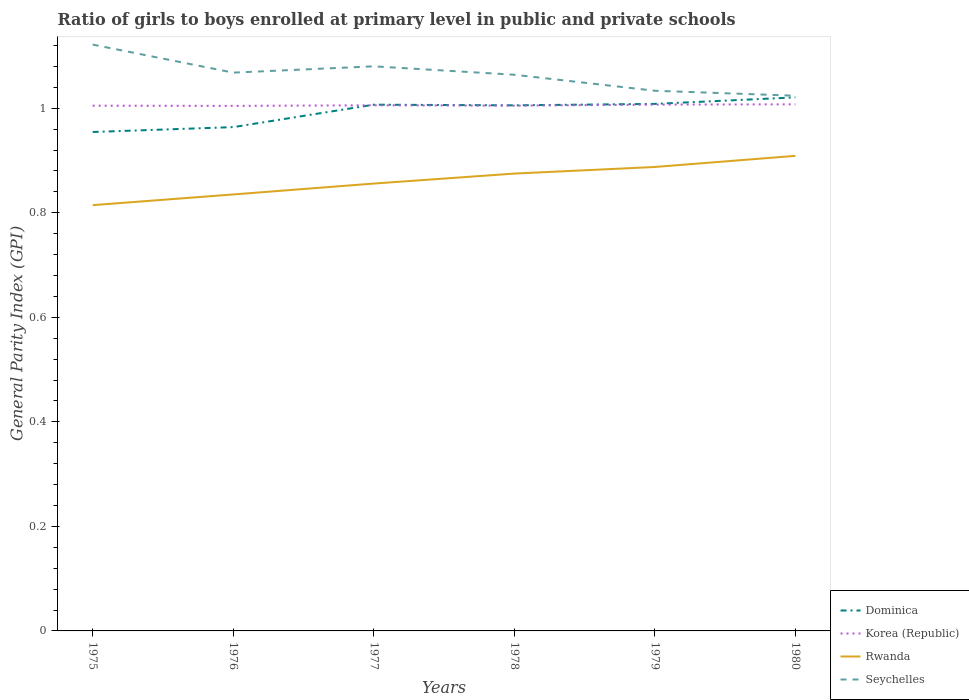Is the number of lines equal to the number of legend labels?
Offer a terse response. Yes. Across all years, what is the maximum general parity index in Seychelles?
Ensure brevity in your answer.  1.02. In which year was the general parity index in Rwanda maximum?
Your answer should be compact. 1975. What is the total general parity index in Korea (Republic) in the graph?
Provide a short and direct response. -0. What is the difference between the highest and the second highest general parity index in Korea (Republic)?
Offer a terse response. 0. Is the general parity index in Korea (Republic) strictly greater than the general parity index in Seychelles over the years?
Give a very brief answer. Yes. How many years are there in the graph?
Offer a terse response. 6. Does the graph contain any zero values?
Your response must be concise. No. Does the graph contain grids?
Give a very brief answer. No. How many legend labels are there?
Offer a terse response. 4. What is the title of the graph?
Offer a terse response. Ratio of girls to boys enrolled at primary level in public and private schools. Does "Morocco" appear as one of the legend labels in the graph?
Keep it short and to the point. No. What is the label or title of the X-axis?
Your answer should be compact. Years. What is the label or title of the Y-axis?
Ensure brevity in your answer.  General Parity Index (GPI). What is the General Parity Index (GPI) of Dominica in 1975?
Give a very brief answer. 0.95. What is the General Parity Index (GPI) in Korea (Republic) in 1975?
Provide a succinct answer. 1. What is the General Parity Index (GPI) in Rwanda in 1975?
Your answer should be very brief. 0.81. What is the General Parity Index (GPI) in Seychelles in 1975?
Provide a short and direct response. 1.12. What is the General Parity Index (GPI) of Dominica in 1976?
Ensure brevity in your answer.  0.96. What is the General Parity Index (GPI) in Korea (Republic) in 1976?
Make the answer very short. 1. What is the General Parity Index (GPI) in Rwanda in 1976?
Provide a succinct answer. 0.83. What is the General Parity Index (GPI) of Seychelles in 1976?
Ensure brevity in your answer.  1.07. What is the General Parity Index (GPI) of Dominica in 1977?
Your response must be concise. 1.01. What is the General Parity Index (GPI) in Korea (Republic) in 1977?
Make the answer very short. 1.01. What is the General Parity Index (GPI) in Rwanda in 1977?
Provide a succinct answer. 0.86. What is the General Parity Index (GPI) of Seychelles in 1977?
Offer a terse response. 1.08. What is the General Parity Index (GPI) of Dominica in 1978?
Make the answer very short. 1.01. What is the General Parity Index (GPI) of Korea (Republic) in 1978?
Ensure brevity in your answer.  1. What is the General Parity Index (GPI) of Rwanda in 1978?
Keep it short and to the point. 0.87. What is the General Parity Index (GPI) in Seychelles in 1978?
Your answer should be very brief. 1.06. What is the General Parity Index (GPI) of Dominica in 1979?
Ensure brevity in your answer.  1.01. What is the General Parity Index (GPI) in Korea (Republic) in 1979?
Your answer should be very brief. 1.01. What is the General Parity Index (GPI) in Rwanda in 1979?
Your answer should be compact. 0.89. What is the General Parity Index (GPI) of Seychelles in 1979?
Keep it short and to the point. 1.03. What is the General Parity Index (GPI) in Dominica in 1980?
Give a very brief answer. 1.02. What is the General Parity Index (GPI) of Korea (Republic) in 1980?
Offer a terse response. 1.01. What is the General Parity Index (GPI) of Rwanda in 1980?
Your response must be concise. 0.91. What is the General Parity Index (GPI) of Seychelles in 1980?
Offer a very short reply. 1.02. Across all years, what is the maximum General Parity Index (GPI) of Dominica?
Your answer should be very brief. 1.02. Across all years, what is the maximum General Parity Index (GPI) of Korea (Republic)?
Your answer should be very brief. 1.01. Across all years, what is the maximum General Parity Index (GPI) in Rwanda?
Your answer should be very brief. 0.91. Across all years, what is the maximum General Parity Index (GPI) of Seychelles?
Offer a terse response. 1.12. Across all years, what is the minimum General Parity Index (GPI) in Dominica?
Give a very brief answer. 0.95. Across all years, what is the minimum General Parity Index (GPI) of Korea (Republic)?
Give a very brief answer. 1. Across all years, what is the minimum General Parity Index (GPI) of Rwanda?
Make the answer very short. 0.81. Across all years, what is the minimum General Parity Index (GPI) of Seychelles?
Make the answer very short. 1.02. What is the total General Parity Index (GPI) of Dominica in the graph?
Your answer should be very brief. 5.96. What is the total General Parity Index (GPI) in Korea (Republic) in the graph?
Make the answer very short. 6.03. What is the total General Parity Index (GPI) in Rwanda in the graph?
Make the answer very short. 5.18. What is the total General Parity Index (GPI) in Seychelles in the graph?
Provide a succinct answer. 6.39. What is the difference between the General Parity Index (GPI) of Dominica in 1975 and that in 1976?
Provide a short and direct response. -0.01. What is the difference between the General Parity Index (GPI) in Rwanda in 1975 and that in 1976?
Your response must be concise. -0.02. What is the difference between the General Parity Index (GPI) of Seychelles in 1975 and that in 1976?
Make the answer very short. 0.05. What is the difference between the General Parity Index (GPI) in Dominica in 1975 and that in 1977?
Keep it short and to the point. -0.05. What is the difference between the General Parity Index (GPI) in Korea (Republic) in 1975 and that in 1977?
Provide a succinct answer. -0. What is the difference between the General Parity Index (GPI) of Rwanda in 1975 and that in 1977?
Give a very brief answer. -0.04. What is the difference between the General Parity Index (GPI) in Seychelles in 1975 and that in 1977?
Your answer should be very brief. 0.04. What is the difference between the General Parity Index (GPI) of Dominica in 1975 and that in 1978?
Your response must be concise. -0.05. What is the difference between the General Parity Index (GPI) of Rwanda in 1975 and that in 1978?
Give a very brief answer. -0.06. What is the difference between the General Parity Index (GPI) in Seychelles in 1975 and that in 1978?
Keep it short and to the point. 0.06. What is the difference between the General Parity Index (GPI) in Dominica in 1975 and that in 1979?
Your response must be concise. -0.05. What is the difference between the General Parity Index (GPI) in Korea (Republic) in 1975 and that in 1979?
Your response must be concise. -0. What is the difference between the General Parity Index (GPI) of Rwanda in 1975 and that in 1979?
Provide a succinct answer. -0.07. What is the difference between the General Parity Index (GPI) of Seychelles in 1975 and that in 1979?
Provide a short and direct response. 0.09. What is the difference between the General Parity Index (GPI) of Dominica in 1975 and that in 1980?
Provide a short and direct response. -0.07. What is the difference between the General Parity Index (GPI) of Korea (Republic) in 1975 and that in 1980?
Provide a short and direct response. -0. What is the difference between the General Parity Index (GPI) in Rwanda in 1975 and that in 1980?
Your answer should be very brief. -0.09. What is the difference between the General Parity Index (GPI) in Seychelles in 1975 and that in 1980?
Offer a very short reply. 0.1. What is the difference between the General Parity Index (GPI) of Dominica in 1976 and that in 1977?
Your answer should be compact. -0.04. What is the difference between the General Parity Index (GPI) of Korea (Republic) in 1976 and that in 1977?
Give a very brief answer. -0. What is the difference between the General Parity Index (GPI) in Rwanda in 1976 and that in 1977?
Offer a terse response. -0.02. What is the difference between the General Parity Index (GPI) of Seychelles in 1976 and that in 1977?
Ensure brevity in your answer.  -0.01. What is the difference between the General Parity Index (GPI) of Dominica in 1976 and that in 1978?
Your answer should be very brief. -0.04. What is the difference between the General Parity Index (GPI) of Korea (Republic) in 1976 and that in 1978?
Offer a terse response. -0. What is the difference between the General Parity Index (GPI) of Rwanda in 1976 and that in 1978?
Keep it short and to the point. -0.04. What is the difference between the General Parity Index (GPI) in Seychelles in 1976 and that in 1978?
Ensure brevity in your answer.  0. What is the difference between the General Parity Index (GPI) of Dominica in 1976 and that in 1979?
Keep it short and to the point. -0.04. What is the difference between the General Parity Index (GPI) in Korea (Republic) in 1976 and that in 1979?
Give a very brief answer. -0. What is the difference between the General Parity Index (GPI) of Rwanda in 1976 and that in 1979?
Your response must be concise. -0.05. What is the difference between the General Parity Index (GPI) of Seychelles in 1976 and that in 1979?
Provide a short and direct response. 0.03. What is the difference between the General Parity Index (GPI) in Dominica in 1976 and that in 1980?
Your answer should be very brief. -0.06. What is the difference between the General Parity Index (GPI) of Korea (Republic) in 1976 and that in 1980?
Provide a short and direct response. -0. What is the difference between the General Parity Index (GPI) in Rwanda in 1976 and that in 1980?
Keep it short and to the point. -0.07. What is the difference between the General Parity Index (GPI) in Seychelles in 1976 and that in 1980?
Ensure brevity in your answer.  0.04. What is the difference between the General Parity Index (GPI) of Dominica in 1977 and that in 1978?
Ensure brevity in your answer.  0. What is the difference between the General Parity Index (GPI) of Korea (Republic) in 1977 and that in 1978?
Your response must be concise. 0. What is the difference between the General Parity Index (GPI) in Rwanda in 1977 and that in 1978?
Ensure brevity in your answer.  -0.02. What is the difference between the General Parity Index (GPI) in Seychelles in 1977 and that in 1978?
Offer a very short reply. 0.02. What is the difference between the General Parity Index (GPI) of Dominica in 1977 and that in 1979?
Keep it short and to the point. -0. What is the difference between the General Parity Index (GPI) of Korea (Republic) in 1977 and that in 1979?
Make the answer very short. -0. What is the difference between the General Parity Index (GPI) of Rwanda in 1977 and that in 1979?
Provide a succinct answer. -0.03. What is the difference between the General Parity Index (GPI) in Seychelles in 1977 and that in 1979?
Give a very brief answer. 0.05. What is the difference between the General Parity Index (GPI) in Dominica in 1977 and that in 1980?
Offer a terse response. -0.01. What is the difference between the General Parity Index (GPI) of Korea (Republic) in 1977 and that in 1980?
Make the answer very short. -0. What is the difference between the General Parity Index (GPI) in Rwanda in 1977 and that in 1980?
Your answer should be compact. -0.05. What is the difference between the General Parity Index (GPI) in Seychelles in 1977 and that in 1980?
Provide a short and direct response. 0.06. What is the difference between the General Parity Index (GPI) of Dominica in 1978 and that in 1979?
Make the answer very short. -0. What is the difference between the General Parity Index (GPI) in Korea (Republic) in 1978 and that in 1979?
Offer a terse response. -0. What is the difference between the General Parity Index (GPI) in Rwanda in 1978 and that in 1979?
Provide a short and direct response. -0.01. What is the difference between the General Parity Index (GPI) in Seychelles in 1978 and that in 1979?
Ensure brevity in your answer.  0.03. What is the difference between the General Parity Index (GPI) in Dominica in 1978 and that in 1980?
Your answer should be compact. -0.02. What is the difference between the General Parity Index (GPI) in Korea (Republic) in 1978 and that in 1980?
Keep it short and to the point. -0. What is the difference between the General Parity Index (GPI) of Rwanda in 1978 and that in 1980?
Make the answer very short. -0.03. What is the difference between the General Parity Index (GPI) of Seychelles in 1978 and that in 1980?
Provide a succinct answer. 0.04. What is the difference between the General Parity Index (GPI) of Dominica in 1979 and that in 1980?
Keep it short and to the point. -0.01. What is the difference between the General Parity Index (GPI) in Korea (Republic) in 1979 and that in 1980?
Offer a very short reply. -0. What is the difference between the General Parity Index (GPI) in Rwanda in 1979 and that in 1980?
Make the answer very short. -0.02. What is the difference between the General Parity Index (GPI) of Seychelles in 1979 and that in 1980?
Provide a short and direct response. 0.01. What is the difference between the General Parity Index (GPI) in Dominica in 1975 and the General Parity Index (GPI) in Korea (Republic) in 1976?
Provide a short and direct response. -0.05. What is the difference between the General Parity Index (GPI) of Dominica in 1975 and the General Parity Index (GPI) of Rwanda in 1976?
Offer a terse response. 0.12. What is the difference between the General Parity Index (GPI) of Dominica in 1975 and the General Parity Index (GPI) of Seychelles in 1976?
Keep it short and to the point. -0.11. What is the difference between the General Parity Index (GPI) in Korea (Republic) in 1975 and the General Parity Index (GPI) in Rwanda in 1976?
Your answer should be very brief. 0.17. What is the difference between the General Parity Index (GPI) in Korea (Republic) in 1975 and the General Parity Index (GPI) in Seychelles in 1976?
Offer a very short reply. -0.06. What is the difference between the General Parity Index (GPI) of Rwanda in 1975 and the General Parity Index (GPI) of Seychelles in 1976?
Provide a short and direct response. -0.25. What is the difference between the General Parity Index (GPI) of Dominica in 1975 and the General Parity Index (GPI) of Korea (Republic) in 1977?
Your response must be concise. -0.05. What is the difference between the General Parity Index (GPI) of Dominica in 1975 and the General Parity Index (GPI) of Rwanda in 1977?
Your answer should be very brief. 0.1. What is the difference between the General Parity Index (GPI) in Dominica in 1975 and the General Parity Index (GPI) in Seychelles in 1977?
Offer a terse response. -0.13. What is the difference between the General Parity Index (GPI) in Korea (Republic) in 1975 and the General Parity Index (GPI) in Rwanda in 1977?
Provide a short and direct response. 0.15. What is the difference between the General Parity Index (GPI) in Korea (Republic) in 1975 and the General Parity Index (GPI) in Seychelles in 1977?
Give a very brief answer. -0.08. What is the difference between the General Parity Index (GPI) of Rwanda in 1975 and the General Parity Index (GPI) of Seychelles in 1977?
Make the answer very short. -0.27. What is the difference between the General Parity Index (GPI) in Dominica in 1975 and the General Parity Index (GPI) in Korea (Republic) in 1978?
Offer a terse response. -0.05. What is the difference between the General Parity Index (GPI) in Dominica in 1975 and the General Parity Index (GPI) in Rwanda in 1978?
Keep it short and to the point. 0.08. What is the difference between the General Parity Index (GPI) of Dominica in 1975 and the General Parity Index (GPI) of Seychelles in 1978?
Your response must be concise. -0.11. What is the difference between the General Parity Index (GPI) of Korea (Republic) in 1975 and the General Parity Index (GPI) of Rwanda in 1978?
Provide a short and direct response. 0.13. What is the difference between the General Parity Index (GPI) of Korea (Republic) in 1975 and the General Parity Index (GPI) of Seychelles in 1978?
Offer a terse response. -0.06. What is the difference between the General Parity Index (GPI) in Rwanda in 1975 and the General Parity Index (GPI) in Seychelles in 1978?
Ensure brevity in your answer.  -0.25. What is the difference between the General Parity Index (GPI) of Dominica in 1975 and the General Parity Index (GPI) of Korea (Republic) in 1979?
Your response must be concise. -0.05. What is the difference between the General Parity Index (GPI) of Dominica in 1975 and the General Parity Index (GPI) of Rwanda in 1979?
Offer a terse response. 0.07. What is the difference between the General Parity Index (GPI) in Dominica in 1975 and the General Parity Index (GPI) in Seychelles in 1979?
Provide a short and direct response. -0.08. What is the difference between the General Parity Index (GPI) of Korea (Republic) in 1975 and the General Parity Index (GPI) of Rwanda in 1979?
Provide a succinct answer. 0.12. What is the difference between the General Parity Index (GPI) in Korea (Republic) in 1975 and the General Parity Index (GPI) in Seychelles in 1979?
Your response must be concise. -0.03. What is the difference between the General Parity Index (GPI) of Rwanda in 1975 and the General Parity Index (GPI) of Seychelles in 1979?
Offer a terse response. -0.22. What is the difference between the General Parity Index (GPI) of Dominica in 1975 and the General Parity Index (GPI) of Korea (Republic) in 1980?
Provide a succinct answer. -0.05. What is the difference between the General Parity Index (GPI) of Dominica in 1975 and the General Parity Index (GPI) of Rwanda in 1980?
Make the answer very short. 0.05. What is the difference between the General Parity Index (GPI) of Dominica in 1975 and the General Parity Index (GPI) of Seychelles in 1980?
Your answer should be compact. -0.07. What is the difference between the General Parity Index (GPI) in Korea (Republic) in 1975 and the General Parity Index (GPI) in Rwanda in 1980?
Make the answer very short. 0.1. What is the difference between the General Parity Index (GPI) of Korea (Republic) in 1975 and the General Parity Index (GPI) of Seychelles in 1980?
Provide a short and direct response. -0.02. What is the difference between the General Parity Index (GPI) of Rwanda in 1975 and the General Parity Index (GPI) of Seychelles in 1980?
Offer a very short reply. -0.21. What is the difference between the General Parity Index (GPI) of Dominica in 1976 and the General Parity Index (GPI) of Korea (Republic) in 1977?
Give a very brief answer. -0.04. What is the difference between the General Parity Index (GPI) in Dominica in 1976 and the General Parity Index (GPI) in Rwanda in 1977?
Ensure brevity in your answer.  0.11. What is the difference between the General Parity Index (GPI) of Dominica in 1976 and the General Parity Index (GPI) of Seychelles in 1977?
Your answer should be very brief. -0.12. What is the difference between the General Parity Index (GPI) in Korea (Republic) in 1976 and the General Parity Index (GPI) in Rwanda in 1977?
Give a very brief answer. 0.15. What is the difference between the General Parity Index (GPI) of Korea (Republic) in 1976 and the General Parity Index (GPI) of Seychelles in 1977?
Offer a very short reply. -0.08. What is the difference between the General Parity Index (GPI) of Rwanda in 1976 and the General Parity Index (GPI) of Seychelles in 1977?
Your response must be concise. -0.25. What is the difference between the General Parity Index (GPI) in Dominica in 1976 and the General Parity Index (GPI) in Korea (Republic) in 1978?
Offer a terse response. -0.04. What is the difference between the General Parity Index (GPI) in Dominica in 1976 and the General Parity Index (GPI) in Rwanda in 1978?
Provide a succinct answer. 0.09. What is the difference between the General Parity Index (GPI) in Dominica in 1976 and the General Parity Index (GPI) in Seychelles in 1978?
Provide a short and direct response. -0.1. What is the difference between the General Parity Index (GPI) in Korea (Republic) in 1976 and the General Parity Index (GPI) in Rwanda in 1978?
Your answer should be compact. 0.13. What is the difference between the General Parity Index (GPI) of Korea (Republic) in 1976 and the General Parity Index (GPI) of Seychelles in 1978?
Your response must be concise. -0.06. What is the difference between the General Parity Index (GPI) in Rwanda in 1976 and the General Parity Index (GPI) in Seychelles in 1978?
Your response must be concise. -0.23. What is the difference between the General Parity Index (GPI) of Dominica in 1976 and the General Parity Index (GPI) of Korea (Republic) in 1979?
Your response must be concise. -0.04. What is the difference between the General Parity Index (GPI) in Dominica in 1976 and the General Parity Index (GPI) in Rwanda in 1979?
Provide a succinct answer. 0.08. What is the difference between the General Parity Index (GPI) in Dominica in 1976 and the General Parity Index (GPI) in Seychelles in 1979?
Keep it short and to the point. -0.07. What is the difference between the General Parity Index (GPI) in Korea (Republic) in 1976 and the General Parity Index (GPI) in Rwanda in 1979?
Give a very brief answer. 0.12. What is the difference between the General Parity Index (GPI) in Korea (Republic) in 1976 and the General Parity Index (GPI) in Seychelles in 1979?
Make the answer very short. -0.03. What is the difference between the General Parity Index (GPI) of Rwanda in 1976 and the General Parity Index (GPI) of Seychelles in 1979?
Your answer should be very brief. -0.2. What is the difference between the General Parity Index (GPI) in Dominica in 1976 and the General Parity Index (GPI) in Korea (Republic) in 1980?
Make the answer very short. -0.04. What is the difference between the General Parity Index (GPI) in Dominica in 1976 and the General Parity Index (GPI) in Rwanda in 1980?
Ensure brevity in your answer.  0.06. What is the difference between the General Parity Index (GPI) in Dominica in 1976 and the General Parity Index (GPI) in Seychelles in 1980?
Give a very brief answer. -0.06. What is the difference between the General Parity Index (GPI) of Korea (Republic) in 1976 and the General Parity Index (GPI) of Rwanda in 1980?
Make the answer very short. 0.1. What is the difference between the General Parity Index (GPI) of Korea (Republic) in 1976 and the General Parity Index (GPI) of Seychelles in 1980?
Your answer should be very brief. -0.02. What is the difference between the General Parity Index (GPI) in Rwanda in 1976 and the General Parity Index (GPI) in Seychelles in 1980?
Your answer should be very brief. -0.19. What is the difference between the General Parity Index (GPI) in Dominica in 1977 and the General Parity Index (GPI) in Korea (Republic) in 1978?
Provide a succinct answer. 0. What is the difference between the General Parity Index (GPI) of Dominica in 1977 and the General Parity Index (GPI) of Rwanda in 1978?
Provide a succinct answer. 0.13. What is the difference between the General Parity Index (GPI) in Dominica in 1977 and the General Parity Index (GPI) in Seychelles in 1978?
Provide a short and direct response. -0.06. What is the difference between the General Parity Index (GPI) in Korea (Republic) in 1977 and the General Parity Index (GPI) in Rwanda in 1978?
Give a very brief answer. 0.13. What is the difference between the General Parity Index (GPI) of Korea (Republic) in 1977 and the General Parity Index (GPI) of Seychelles in 1978?
Keep it short and to the point. -0.06. What is the difference between the General Parity Index (GPI) in Rwanda in 1977 and the General Parity Index (GPI) in Seychelles in 1978?
Your response must be concise. -0.21. What is the difference between the General Parity Index (GPI) of Dominica in 1977 and the General Parity Index (GPI) of Korea (Republic) in 1979?
Your answer should be compact. -0. What is the difference between the General Parity Index (GPI) in Dominica in 1977 and the General Parity Index (GPI) in Rwanda in 1979?
Keep it short and to the point. 0.12. What is the difference between the General Parity Index (GPI) in Dominica in 1977 and the General Parity Index (GPI) in Seychelles in 1979?
Offer a terse response. -0.03. What is the difference between the General Parity Index (GPI) in Korea (Republic) in 1977 and the General Parity Index (GPI) in Rwanda in 1979?
Make the answer very short. 0.12. What is the difference between the General Parity Index (GPI) of Korea (Republic) in 1977 and the General Parity Index (GPI) of Seychelles in 1979?
Provide a succinct answer. -0.03. What is the difference between the General Parity Index (GPI) of Rwanda in 1977 and the General Parity Index (GPI) of Seychelles in 1979?
Offer a terse response. -0.18. What is the difference between the General Parity Index (GPI) in Dominica in 1977 and the General Parity Index (GPI) in Korea (Republic) in 1980?
Provide a short and direct response. -0. What is the difference between the General Parity Index (GPI) of Dominica in 1977 and the General Parity Index (GPI) of Rwanda in 1980?
Your answer should be very brief. 0.1. What is the difference between the General Parity Index (GPI) of Dominica in 1977 and the General Parity Index (GPI) of Seychelles in 1980?
Keep it short and to the point. -0.02. What is the difference between the General Parity Index (GPI) in Korea (Republic) in 1977 and the General Parity Index (GPI) in Rwanda in 1980?
Your response must be concise. 0.1. What is the difference between the General Parity Index (GPI) of Korea (Republic) in 1977 and the General Parity Index (GPI) of Seychelles in 1980?
Offer a terse response. -0.02. What is the difference between the General Parity Index (GPI) of Rwanda in 1977 and the General Parity Index (GPI) of Seychelles in 1980?
Your answer should be compact. -0.17. What is the difference between the General Parity Index (GPI) of Dominica in 1978 and the General Parity Index (GPI) of Korea (Republic) in 1979?
Provide a short and direct response. -0. What is the difference between the General Parity Index (GPI) of Dominica in 1978 and the General Parity Index (GPI) of Rwanda in 1979?
Provide a short and direct response. 0.12. What is the difference between the General Parity Index (GPI) of Dominica in 1978 and the General Parity Index (GPI) of Seychelles in 1979?
Make the answer very short. -0.03. What is the difference between the General Parity Index (GPI) in Korea (Republic) in 1978 and the General Parity Index (GPI) in Rwanda in 1979?
Provide a succinct answer. 0.12. What is the difference between the General Parity Index (GPI) in Korea (Republic) in 1978 and the General Parity Index (GPI) in Seychelles in 1979?
Keep it short and to the point. -0.03. What is the difference between the General Parity Index (GPI) in Rwanda in 1978 and the General Parity Index (GPI) in Seychelles in 1979?
Provide a succinct answer. -0.16. What is the difference between the General Parity Index (GPI) in Dominica in 1978 and the General Parity Index (GPI) in Korea (Republic) in 1980?
Offer a terse response. -0. What is the difference between the General Parity Index (GPI) in Dominica in 1978 and the General Parity Index (GPI) in Rwanda in 1980?
Give a very brief answer. 0.1. What is the difference between the General Parity Index (GPI) of Dominica in 1978 and the General Parity Index (GPI) of Seychelles in 1980?
Your answer should be very brief. -0.02. What is the difference between the General Parity Index (GPI) in Korea (Republic) in 1978 and the General Parity Index (GPI) in Rwanda in 1980?
Offer a terse response. 0.1. What is the difference between the General Parity Index (GPI) in Korea (Republic) in 1978 and the General Parity Index (GPI) in Seychelles in 1980?
Offer a very short reply. -0.02. What is the difference between the General Parity Index (GPI) in Rwanda in 1978 and the General Parity Index (GPI) in Seychelles in 1980?
Offer a terse response. -0.15. What is the difference between the General Parity Index (GPI) in Dominica in 1979 and the General Parity Index (GPI) in Korea (Republic) in 1980?
Provide a succinct answer. 0. What is the difference between the General Parity Index (GPI) of Dominica in 1979 and the General Parity Index (GPI) of Rwanda in 1980?
Provide a short and direct response. 0.1. What is the difference between the General Parity Index (GPI) in Dominica in 1979 and the General Parity Index (GPI) in Seychelles in 1980?
Keep it short and to the point. -0.02. What is the difference between the General Parity Index (GPI) in Korea (Republic) in 1979 and the General Parity Index (GPI) in Rwanda in 1980?
Offer a terse response. 0.1. What is the difference between the General Parity Index (GPI) in Korea (Republic) in 1979 and the General Parity Index (GPI) in Seychelles in 1980?
Offer a terse response. -0.02. What is the difference between the General Parity Index (GPI) of Rwanda in 1979 and the General Parity Index (GPI) of Seychelles in 1980?
Offer a very short reply. -0.14. What is the average General Parity Index (GPI) in Dominica per year?
Ensure brevity in your answer.  0.99. What is the average General Parity Index (GPI) in Korea (Republic) per year?
Your answer should be very brief. 1.01. What is the average General Parity Index (GPI) in Rwanda per year?
Make the answer very short. 0.86. What is the average General Parity Index (GPI) of Seychelles per year?
Make the answer very short. 1.07. In the year 1975, what is the difference between the General Parity Index (GPI) of Dominica and General Parity Index (GPI) of Korea (Republic)?
Provide a short and direct response. -0.05. In the year 1975, what is the difference between the General Parity Index (GPI) in Dominica and General Parity Index (GPI) in Rwanda?
Your answer should be very brief. 0.14. In the year 1975, what is the difference between the General Parity Index (GPI) of Dominica and General Parity Index (GPI) of Seychelles?
Your answer should be very brief. -0.17. In the year 1975, what is the difference between the General Parity Index (GPI) in Korea (Republic) and General Parity Index (GPI) in Rwanda?
Offer a terse response. 0.19. In the year 1975, what is the difference between the General Parity Index (GPI) in Korea (Republic) and General Parity Index (GPI) in Seychelles?
Provide a succinct answer. -0.12. In the year 1975, what is the difference between the General Parity Index (GPI) of Rwanda and General Parity Index (GPI) of Seychelles?
Provide a short and direct response. -0.31. In the year 1976, what is the difference between the General Parity Index (GPI) in Dominica and General Parity Index (GPI) in Korea (Republic)?
Your answer should be very brief. -0.04. In the year 1976, what is the difference between the General Parity Index (GPI) in Dominica and General Parity Index (GPI) in Rwanda?
Ensure brevity in your answer.  0.13. In the year 1976, what is the difference between the General Parity Index (GPI) of Dominica and General Parity Index (GPI) of Seychelles?
Your response must be concise. -0.1. In the year 1976, what is the difference between the General Parity Index (GPI) of Korea (Republic) and General Parity Index (GPI) of Rwanda?
Provide a succinct answer. 0.17. In the year 1976, what is the difference between the General Parity Index (GPI) in Korea (Republic) and General Parity Index (GPI) in Seychelles?
Your answer should be compact. -0.06. In the year 1976, what is the difference between the General Parity Index (GPI) of Rwanda and General Parity Index (GPI) of Seychelles?
Your response must be concise. -0.23. In the year 1977, what is the difference between the General Parity Index (GPI) of Dominica and General Parity Index (GPI) of Korea (Republic)?
Your answer should be very brief. 0. In the year 1977, what is the difference between the General Parity Index (GPI) of Dominica and General Parity Index (GPI) of Rwanda?
Make the answer very short. 0.15. In the year 1977, what is the difference between the General Parity Index (GPI) of Dominica and General Parity Index (GPI) of Seychelles?
Make the answer very short. -0.07. In the year 1977, what is the difference between the General Parity Index (GPI) of Korea (Republic) and General Parity Index (GPI) of Rwanda?
Your answer should be very brief. 0.15. In the year 1977, what is the difference between the General Parity Index (GPI) in Korea (Republic) and General Parity Index (GPI) in Seychelles?
Your answer should be very brief. -0.07. In the year 1977, what is the difference between the General Parity Index (GPI) in Rwanda and General Parity Index (GPI) in Seychelles?
Provide a succinct answer. -0.22. In the year 1978, what is the difference between the General Parity Index (GPI) of Dominica and General Parity Index (GPI) of Korea (Republic)?
Your answer should be very brief. 0. In the year 1978, what is the difference between the General Parity Index (GPI) of Dominica and General Parity Index (GPI) of Rwanda?
Your response must be concise. 0.13. In the year 1978, what is the difference between the General Parity Index (GPI) in Dominica and General Parity Index (GPI) in Seychelles?
Ensure brevity in your answer.  -0.06. In the year 1978, what is the difference between the General Parity Index (GPI) of Korea (Republic) and General Parity Index (GPI) of Rwanda?
Offer a terse response. 0.13. In the year 1978, what is the difference between the General Parity Index (GPI) of Korea (Republic) and General Parity Index (GPI) of Seychelles?
Provide a succinct answer. -0.06. In the year 1978, what is the difference between the General Parity Index (GPI) in Rwanda and General Parity Index (GPI) in Seychelles?
Your response must be concise. -0.19. In the year 1979, what is the difference between the General Parity Index (GPI) of Dominica and General Parity Index (GPI) of Korea (Republic)?
Offer a terse response. 0. In the year 1979, what is the difference between the General Parity Index (GPI) in Dominica and General Parity Index (GPI) in Rwanda?
Give a very brief answer. 0.12. In the year 1979, what is the difference between the General Parity Index (GPI) in Dominica and General Parity Index (GPI) in Seychelles?
Give a very brief answer. -0.03. In the year 1979, what is the difference between the General Parity Index (GPI) of Korea (Republic) and General Parity Index (GPI) of Rwanda?
Offer a terse response. 0.12. In the year 1979, what is the difference between the General Parity Index (GPI) of Korea (Republic) and General Parity Index (GPI) of Seychelles?
Provide a succinct answer. -0.03. In the year 1979, what is the difference between the General Parity Index (GPI) of Rwanda and General Parity Index (GPI) of Seychelles?
Keep it short and to the point. -0.15. In the year 1980, what is the difference between the General Parity Index (GPI) of Dominica and General Parity Index (GPI) of Korea (Republic)?
Make the answer very short. 0.01. In the year 1980, what is the difference between the General Parity Index (GPI) of Dominica and General Parity Index (GPI) of Rwanda?
Your response must be concise. 0.11. In the year 1980, what is the difference between the General Parity Index (GPI) in Dominica and General Parity Index (GPI) in Seychelles?
Provide a succinct answer. -0. In the year 1980, what is the difference between the General Parity Index (GPI) of Korea (Republic) and General Parity Index (GPI) of Rwanda?
Make the answer very short. 0.1. In the year 1980, what is the difference between the General Parity Index (GPI) of Korea (Republic) and General Parity Index (GPI) of Seychelles?
Make the answer very short. -0.02. In the year 1980, what is the difference between the General Parity Index (GPI) in Rwanda and General Parity Index (GPI) in Seychelles?
Provide a short and direct response. -0.12. What is the ratio of the General Parity Index (GPI) in Dominica in 1975 to that in 1976?
Offer a very short reply. 0.99. What is the ratio of the General Parity Index (GPI) of Korea (Republic) in 1975 to that in 1976?
Offer a terse response. 1. What is the ratio of the General Parity Index (GPI) in Rwanda in 1975 to that in 1976?
Give a very brief answer. 0.98. What is the ratio of the General Parity Index (GPI) of Seychelles in 1975 to that in 1976?
Ensure brevity in your answer.  1.05. What is the ratio of the General Parity Index (GPI) of Dominica in 1975 to that in 1977?
Keep it short and to the point. 0.95. What is the ratio of the General Parity Index (GPI) of Korea (Republic) in 1975 to that in 1977?
Ensure brevity in your answer.  1. What is the ratio of the General Parity Index (GPI) of Rwanda in 1975 to that in 1977?
Keep it short and to the point. 0.95. What is the ratio of the General Parity Index (GPI) in Seychelles in 1975 to that in 1977?
Your answer should be compact. 1.04. What is the ratio of the General Parity Index (GPI) in Dominica in 1975 to that in 1978?
Ensure brevity in your answer.  0.95. What is the ratio of the General Parity Index (GPI) of Korea (Republic) in 1975 to that in 1978?
Your answer should be very brief. 1. What is the ratio of the General Parity Index (GPI) of Rwanda in 1975 to that in 1978?
Your answer should be compact. 0.93. What is the ratio of the General Parity Index (GPI) in Seychelles in 1975 to that in 1978?
Your response must be concise. 1.05. What is the ratio of the General Parity Index (GPI) in Dominica in 1975 to that in 1979?
Your answer should be very brief. 0.95. What is the ratio of the General Parity Index (GPI) of Rwanda in 1975 to that in 1979?
Give a very brief answer. 0.92. What is the ratio of the General Parity Index (GPI) in Seychelles in 1975 to that in 1979?
Your answer should be very brief. 1.09. What is the ratio of the General Parity Index (GPI) in Dominica in 1975 to that in 1980?
Make the answer very short. 0.94. What is the ratio of the General Parity Index (GPI) in Korea (Republic) in 1975 to that in 1980?
Your response must be concise. 1. What is the ratio of the General Parity Index (GPI) in Rwanda in 1975 to that in 1980?
Your answer should be compact. 0.9. What is the ratio of the General Parity Index (GPI) in Seychelles in 1975 to that in 1980?
Make the answer very short. 1.1. What is the ratio of the General Parity Index (GPI) of Dominica in 1976 to that in 1977?
Ensure brevity in your answer.  0.96. What is the ratio of the General Parity Index (GPI) of Rwanda in 1976 to that in 1977?
Your response must be concise. 0.98. What is the ratio of the General Parity Index (GPI) of Seychelles in 1976 to that in 1977?
Make the answer very short. 0.99. What is the ratio of the General Parity Index (GPI) of Dominica in 1976 to that in 1978?
Your answer should be compact. 0.96. What is the ratio of the General Parity Index (GPI) in Rwanda in 1976 to that in 1978?
Your response must be concise. 0.95. What is the ratio of the General Parity Index (GPI) in Seychelles in 1976 to that in 1978?
Provide a succinct answer. 1. What is the ratio of the General Parity Index (GPI) in Dominica in 1976 to that in 1979?
Make the answer very short. 0.96. What is the ratio of the General Parity Index (GPI) of Rwanda in 1976 to that in 1979?
Offer a terse response. 0.94. What is the ratio of the General Parity Index (GPI) of Seychelles in 1976 to that in 1979?
Offer a very short reply. 1.03. What is the ratio of the General Parity Index (GPI) of Dominica in 1976 to that in 1980?
Keep it short and to the point. 0.94. What is the ratio of the General Parity Index (GPI) of Korea (Republic) in 1976 to that in 1980?
Offer a terse response. 1. What is the ratio of the General Parity Index (GPI) in Rwanda in 1976 to that in 1980?
Offer a terse response. 0.92. What is the ratio of the General Parity Index (GPI) in Seychelles in 1976 to that in 1980?
Offer a terse response. 1.04. What is the ratio of the General Parity Index (GPI) of Dominica in 1977 to that in 1978?
Your answer should be compact. 1. What is the ratio of the General Parity Index (GPI) of Korea (Republic) in 1977 to that in 1978?
Provide a succinct answer. 1. What is the ratio of the General Parity Index (GPI) in Rwanda in 1977 to that in 1978?
Provide a short and direct response. 0.98. What is the ratio of the General Parity Index (GPI) in Seychelles in 1977 to that in 1978?
Offer a very short reply. 1.02. What is the ratio of the General Parity Index (GPI) of Dominica in 1977 to that in 1979?
Make the answer very short. 1. What is the ratio of the General Parity Index (GPI) of Rwanda in 1977 to that in 1979?
Provide a succinct answer. 0.96. What is the ratio of the General Parity Index (GPI) of Seychelles in 1977 to that in 1979?
Offer a terse response. 1.05. What is the ratio of the General Parity Index (GPI) of Dominica in 1977 to that in 1980?
Your answer should be compact. 0.99. What is the ratio of the General Parity Index (GPI) in Korea (Republic) in 1977 to that in 1980?
Make the answer very short. 1. What is the ratio of the General Parity Index (GPI) of Rwanda in 1977 to that in 1980?
Offer a very short reply. 0.94. What is the ratio of the General Parity Index (GPI) in Seychelles in 1977 to that in 1980?
Ensure brevity in your answer.  1.05. What is the ratio of the General Parity Index (GPI) of Dominica in 1978 to that in 1979?
Offer a terse response. 1. What is the ratio of the General Parity Index (GPI) of Rwanda in 1978 to that in 1979?
Keep it short and to the point. 0.99. What is the ratio of the General Parity Index (GPI) of Seychelles in 1978 to that in 1979?
Your answer should be compact. 1.03. What is the ratio of the General Parity Index (GPI) in Dominica in 1978 to that in 1980?
Your answer should be compact. 0.99. What is the ratio of the General Parity Index (GPI) in Korea (Republic) in 1978 to that in 1980?
Give a very brief answer. 1. What is the ratio of the General Parity Index (GPI) of Rwanda in 1978 to that in 1980?
Provide a succinct answer. 0.96. What is the ratio of the General Parity Index (GPI) of Seychelles in 1978 to that in 1980?
Your answer should be very brief. 1.04. What is the ratio of the General Parity Index (GPI) in Rwanda in 1979 to that in 1980?
Make the answer very short. 0.98. What is the ratio of the General Parity Index (GPI) in Seychelles in 1979 to that in 1980?
Ensure brevity in your answer.  1.01. What is the difference between the highest and the second highest General Parity Index (GPI) in Dominica?
Keep it short and to the point. 0.01. What is the difference between the highest and the second highest General Parity Index (GPI) in Korea (Republic)?
Make the answer very short. 0. What is the difference between the highest and the second highest General Parity Index (GPI) in Rwanda?
Your response must be concise. 0.02. What is the difference between the highest and the second highest General Parity Index (GPI) in Seychelles?
Your response must be concise. 0.04. What is the difference between the highest and the lowest General Parity Index (GPI) of Dominica?
Give a very brief answer. 0.07. What is the difference between the highest and the lowest General Parity Index (GPI) in Korea (Republic)?
Your answer should be compact. 0. What is the difference between the highest and the lowest General Parity Index (GPI) in Rwanda?
Your answer should be compact. 0.09. What is the difference between the highest and the lowest General Parity Index (GPI) of Seychelles?
Make the answer very short. 0.1. 